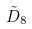Convert formula to latex. <formula><loc_0><loc_0><loc_500><loc_500>\tilde { D } _ { 8 }</formula> 